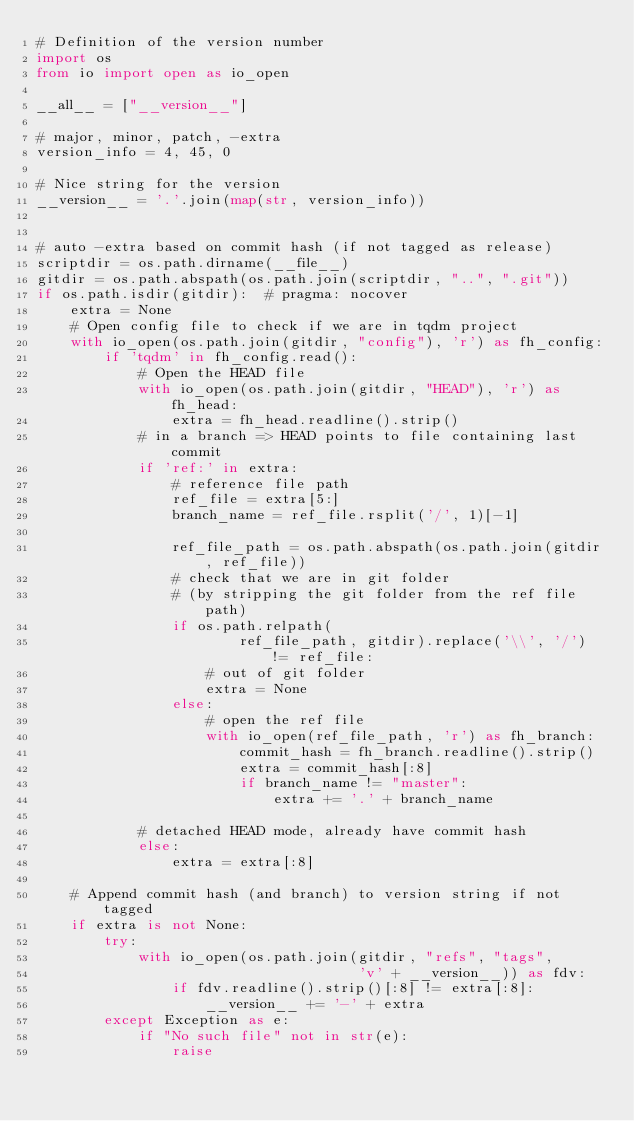Convert code to text. <code><loc_0><loc_0><loc_500><loc_500><_Python_># Definition of the version number
import os
from io import open as io_open

__all__ = ["__version__"]

# major, minor, patch, -extra
version_info = 4, 45, 0

# Nice string for the version
__version__ = '.'.join(map(str, version_info))


# auto -extra based on commit hash (if not tagged as release)
scriptdir = os.path.dirname(__file__)
gitdir = os.path.abspath(os.path.join(scriptdir, "..", ".git"))
if os.path.isdir(gitdir):  # pragma: nocover
    extra = None
    # Open config file to check if we are in tqdm project
    with io_open(os.path.join(gitdir, "config"), 'r') as fh_config:
        if 'tqdm' in fh_config.read():
            # Open the HEAD file
            with io_open(os.path.join(gitdir, "HEAD"), 'r') as fh_head:
                extra = fh_head.readline().strip()
            # in a branch => HEAD points to file containing last commit
            if 'ref:' in extra:
                # reference file path
                ref_file = extra[5:]
                branch_name = ref_file.rsplit('/', 1)[-1]

                ref_file_path = os.path.abspath(os.path.join(gitdir, ref_file))
                # check that we are in git folder
                # (by stripping the git folder from the ref file path)
                if os.path.relpath(
                        ref_file_path, gitdir).replace('\\', '/') != ref_file:
                    # out of git folder
                    extra = None
                else:
                    # open the ref file
                    with io_open(ref_file_path, 'r') as fh_branch:
                        commit_hash = fh_branch.readline().strip()
                        extra = commit_hash[:8]
                        if branch_name != "master":
                            extra += '.' + branch_name

            # detached HEAD mode, already have commit hash
            else:
                extra = extra[:8]

    # Append commit hash (and branch) to version string if not tagged
    if extra is not None:
        try:
            with io_open(os.path.join(gitdir, "refs", "tags",
                                      'v' + __version__)) as fdv:
                if fdv.readline().strip()[:8] != extra[:8]:
                    __version__ += '-' + extra
        except Exception as e:
            if "No such file" not in str(e):
                raise
</code> 